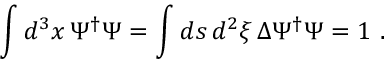<formula> <loc_0><loc_0><loc_500><loc_500>\int d ^ { 3 } x \, \Psi ^ { \dag } \Psi = \int d s \, d ^ { 2 } \xi \, \Delta \Psi ^ { \dag } \Psi = 1 \ .</formula> 